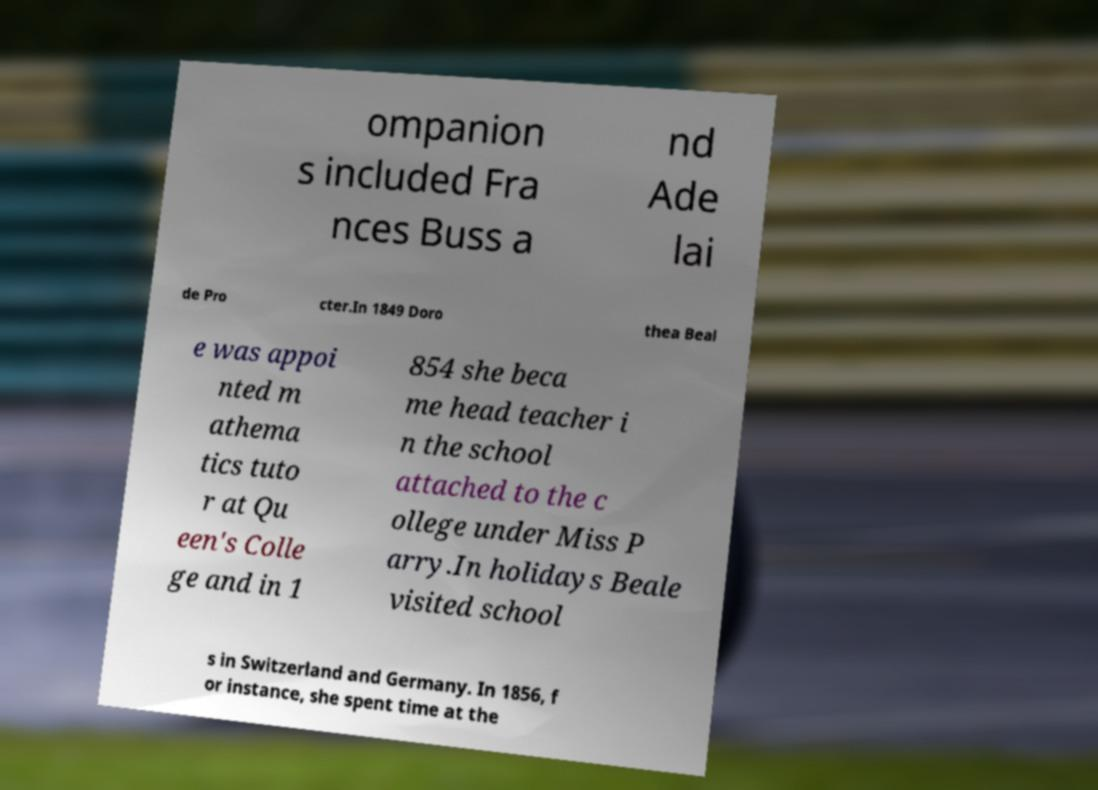I need the written content from this picture converted into text. Can you do that? ompanion s included Fra nces Buss a nd Ade lai de Pro cter.In 1849 Doro thea Beal e was appoi nted m athema tics tuto r at Qu een's Colle ge and in 1 854 she beca me head teacher i n the school attached to the c ollege under Miss P arry.In holidays Beale visited school s in Switzerland and Germany. In 1856, f or instance, she spent time at the 